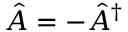Convert formula to latex. <formula><loc_0><loc_0><loc_500><loc_500>\hat { A } = - \hat { A } ^ { \dagger }</formula> 